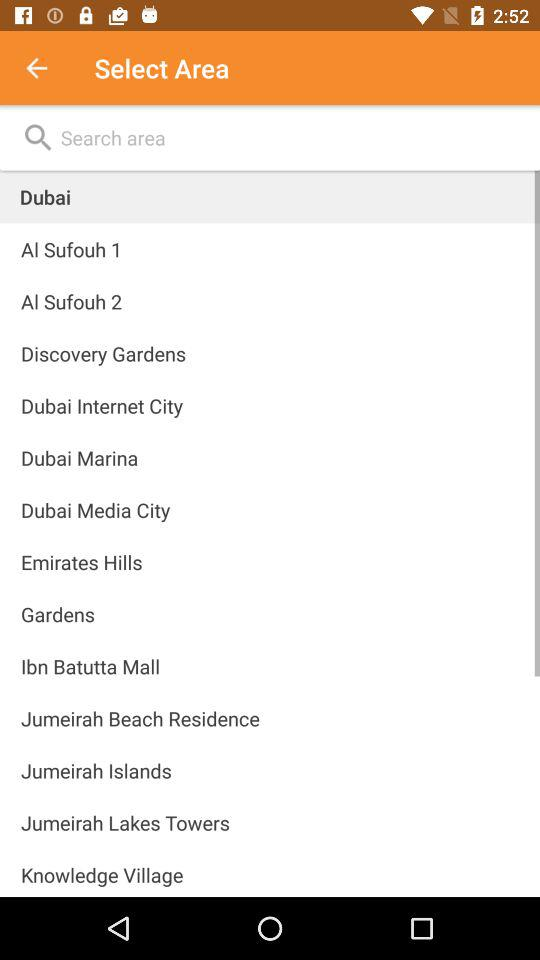What is the selected country's name? The selected country's name is Dubai. 